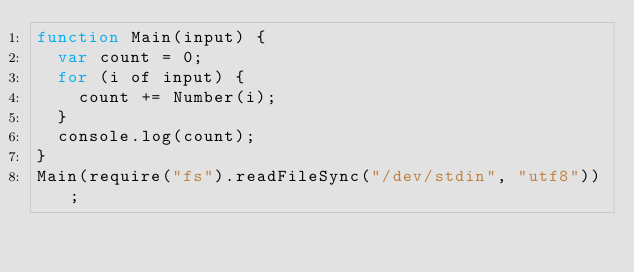<code> <loc_0><loc_0><loc_500><loc_500><_JavaScript_>function Main(input) {
  var count = 0;
  for (i of input) {
    count += Number(i);
  }
  console.log(count);
}
Main(require("fs").readFileSync("/dev/stdin", "utf8"));</code> 